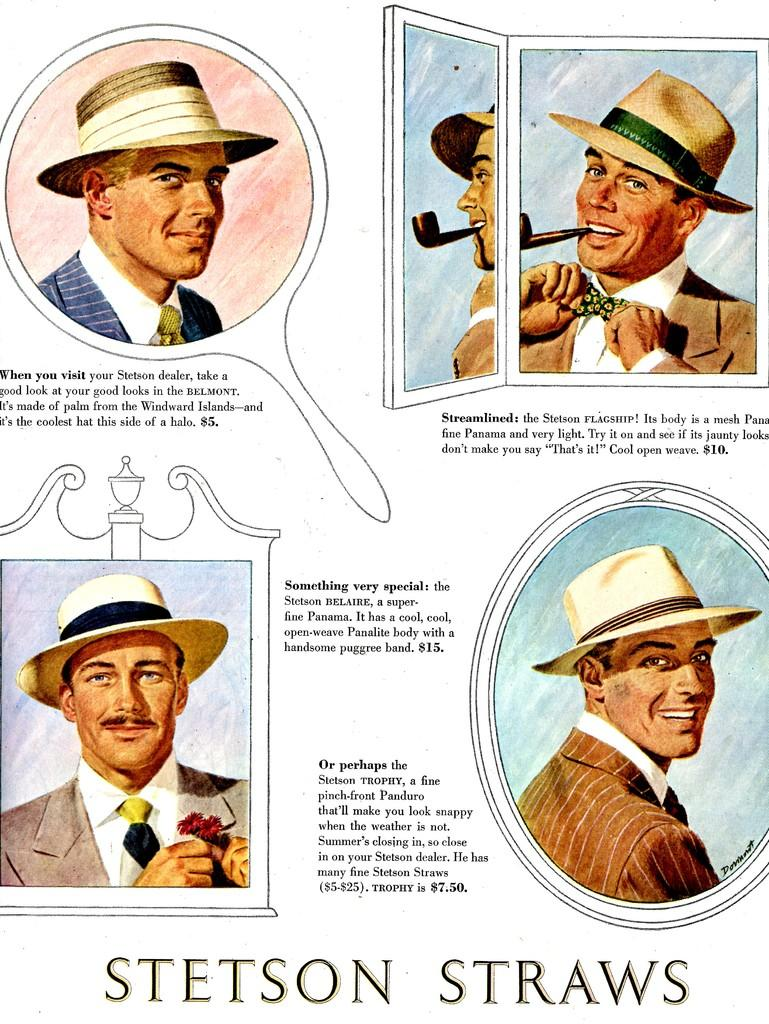What is the main subject of the image? The image is of a page in a book. What type of content is depicted on the page? There are paintings of human faces on the page. Are there any additional elements on the page besides the paintings? Yes, there are notes on the page. How does the cabbage guide the exchange of information on the page? There is no cabbage present in the image, and therefore it cannot guide any exchange of information. 